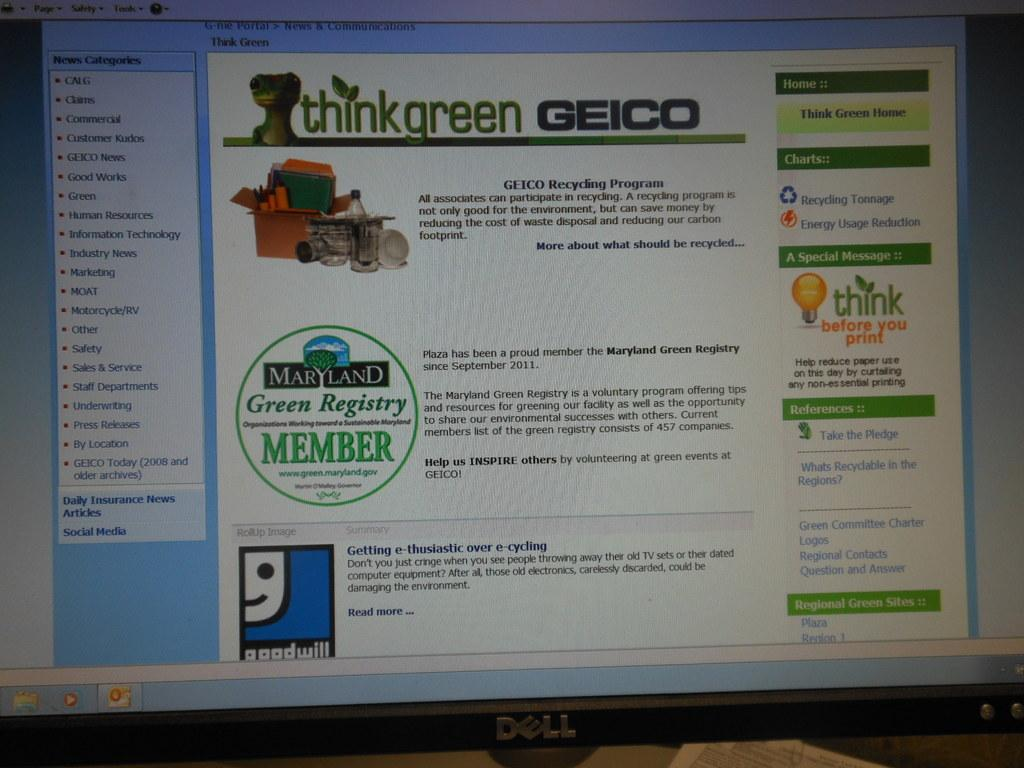What is the main object in the image? There is a screen in the image. What can be seen on the screen? Information is visible on the screen. What type of light source is present in the image? There is a bulb in the image. What is contained within the cardboard box? There are objects in a cardboard box. What type of coal is being used to heat the pot in the image? There is no coal or pot present in the image; it only features a screen, a bulb, and a cardboard box with objects. 